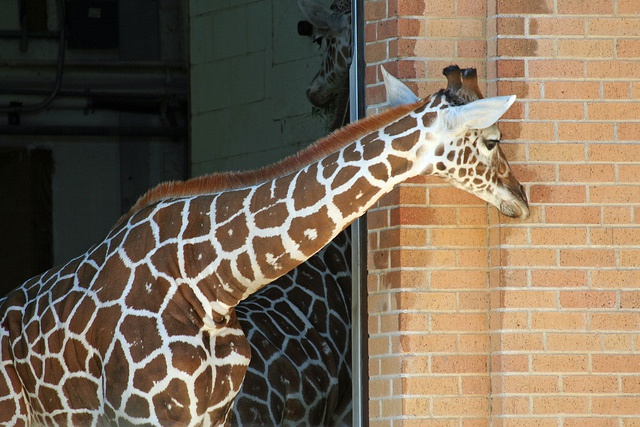Describe the objects in this image and their specific colors. I can see giraffe in black, maroon, lightgray, and gray tones and giraffe in black, gray, and purple tones in this image. 